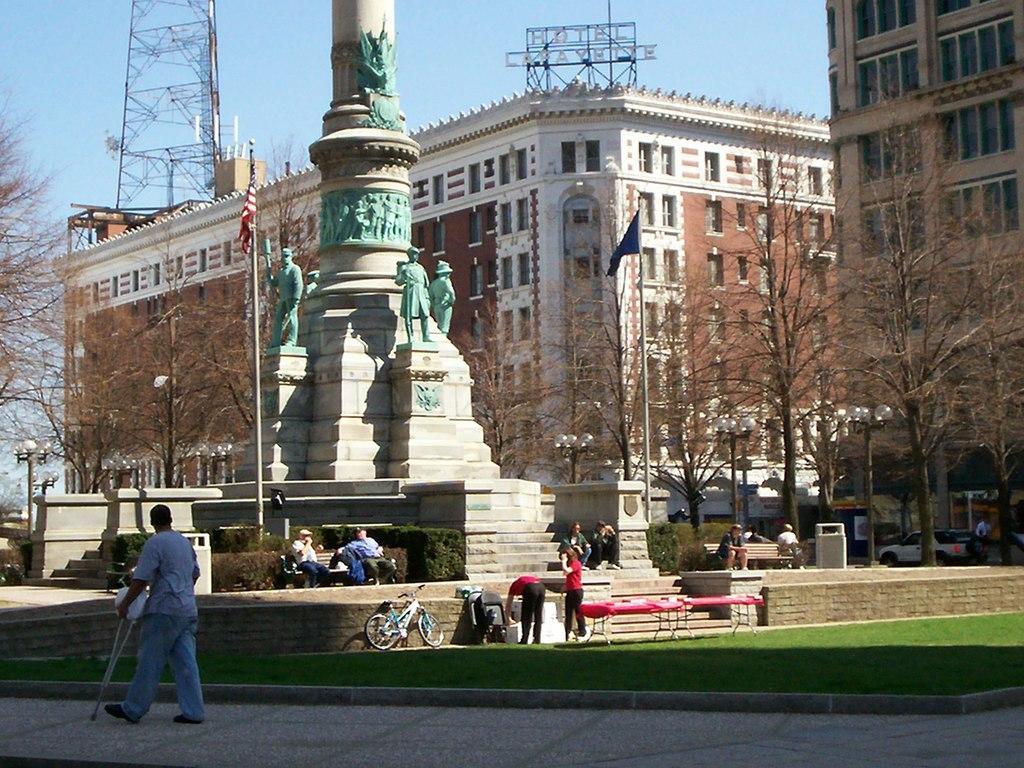Can you describe this image briefly? In the foreground of this image, there is a man walking on the side path with a walking stick. In the background, there is a lawn, statue, stairs, few persons sitting and few are standing and also there is a bicycle, tables, trees, flags, buildings, a tower and the sky. 